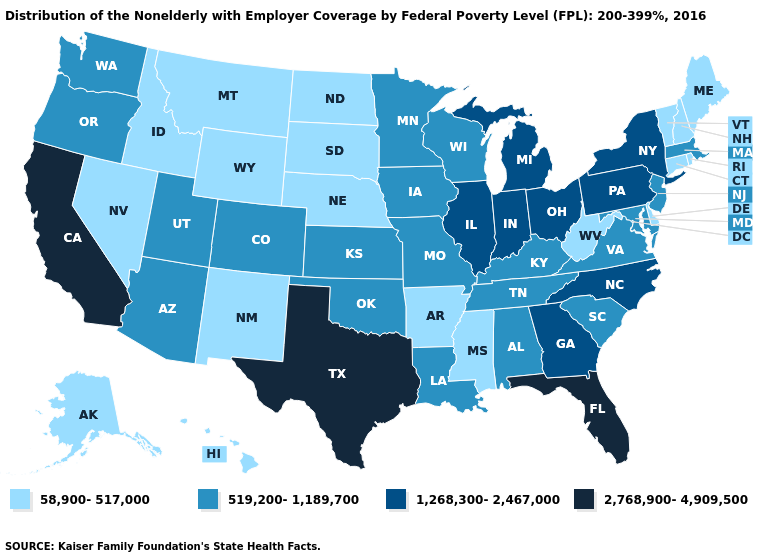What is the value of Vermont?
Answer briefly. 58,900-517,000. Does Tennessee have a higher value than Maine?
Short answer required. Yes. What is the value of Montana?
Keep it brief. 58,900-517,000. What is the value of Utah?
Quick response, please. 519,200-1,189,700. Among the states that border Massachusetts , which have the highest value?
Answer briefly. New York. Does Oregon have a lower value than Florida?
Be succinct. Yes. What is the lowest value in the USA?
Quick response, please. 58,900-517,000. Name the states that have a value in the range 519,200-1,189,700?
Concise answer only. Alabama, Arizona, Colorado, Iowa, Kansas, Kentucky, Louisiana, Maryland, Massachusetts, Minnesota, Missouri, New Jersey, Oklahoma, Oregon, South Carolina, Tennessee, Utah, Virginia, Washington, Wisconsin. What is the value of Louisiana?
Answer briefly. 519,200-1,189,700. Does North Carolina have a lower value than California?
Be succinct. Yes. Does Iowa have the lowest value in the USA?
Quick response, please. No. What is the highest value in states that border Arkansas?
Concise answer only. 2,768,900-4,909,500. What is the lowest value in the West?
Give a very brief answer. 58,900-517,000. Among the states that border South Carolina , which have the lowest value?
Short answer required. Georgia, North Carolina. Does Colorado have the same value as Missouri?
Keep it brief. Yes. 